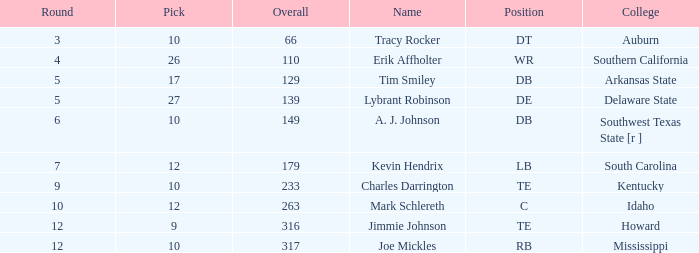What is the sum of Overall, when Name is "Tim Smiley", and when Round is less than 5? None. 